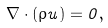<formula> <loc_0><loc_0><loc_500><loc_500>\nabla \cdot ( \rho { u } ) = 0 ,</formula> 